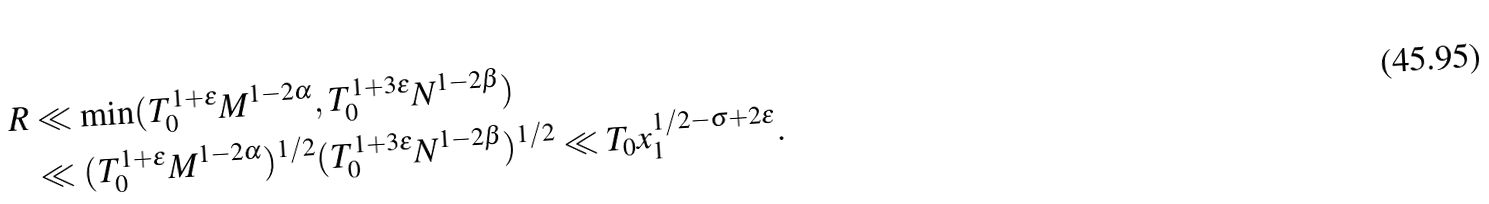Convert formula to latex. <formula><loc_0><loc_0><loc_500><loc_500>R & \ll \min ( T _ { 0 } ^ { 1 + \epsilon } M ^ { 1 - 2 \alpha } , T _ { 0 } ^ { 1 + 3 \epsilon } N ^ { 1 - 2 \beta } ) \\ & \ll ( T _ { 0 } ^ { 1 + \epsilon } M ^ { 1 - 2 \alpha } ) ^ { 1 / 2 } ( T _ { 0 } ^ { 1 + 3 \epsilon } N ^ { 1 - 2 \beta } ) ^ { 1 / 2 } \ll T _ { 0 } x _ { 1 } ^ { 1 / 2 - \sigma + 2 \epsilon } .</formula> 